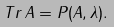<formula> <loc_0><loc_0><loc_500><loc_500>T r \, A = P ( A , \lambda ) .</formula> 